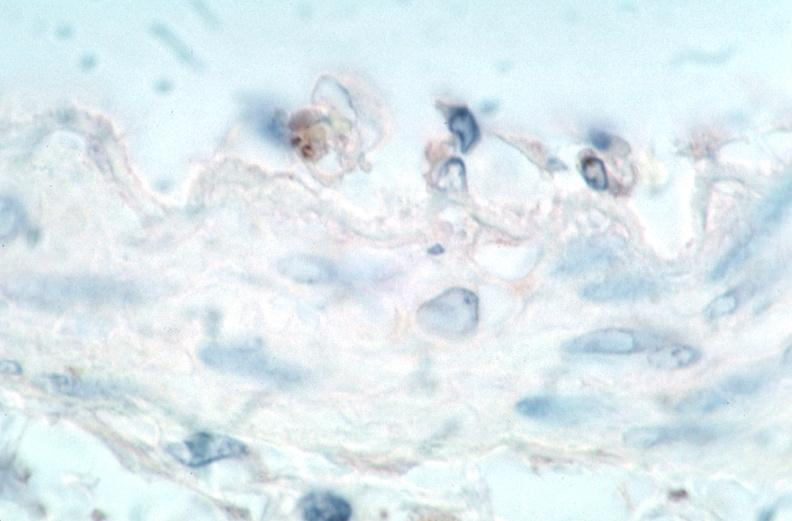does cranial artery show vasculitis?
Answer the question using a single word or phrase. No 